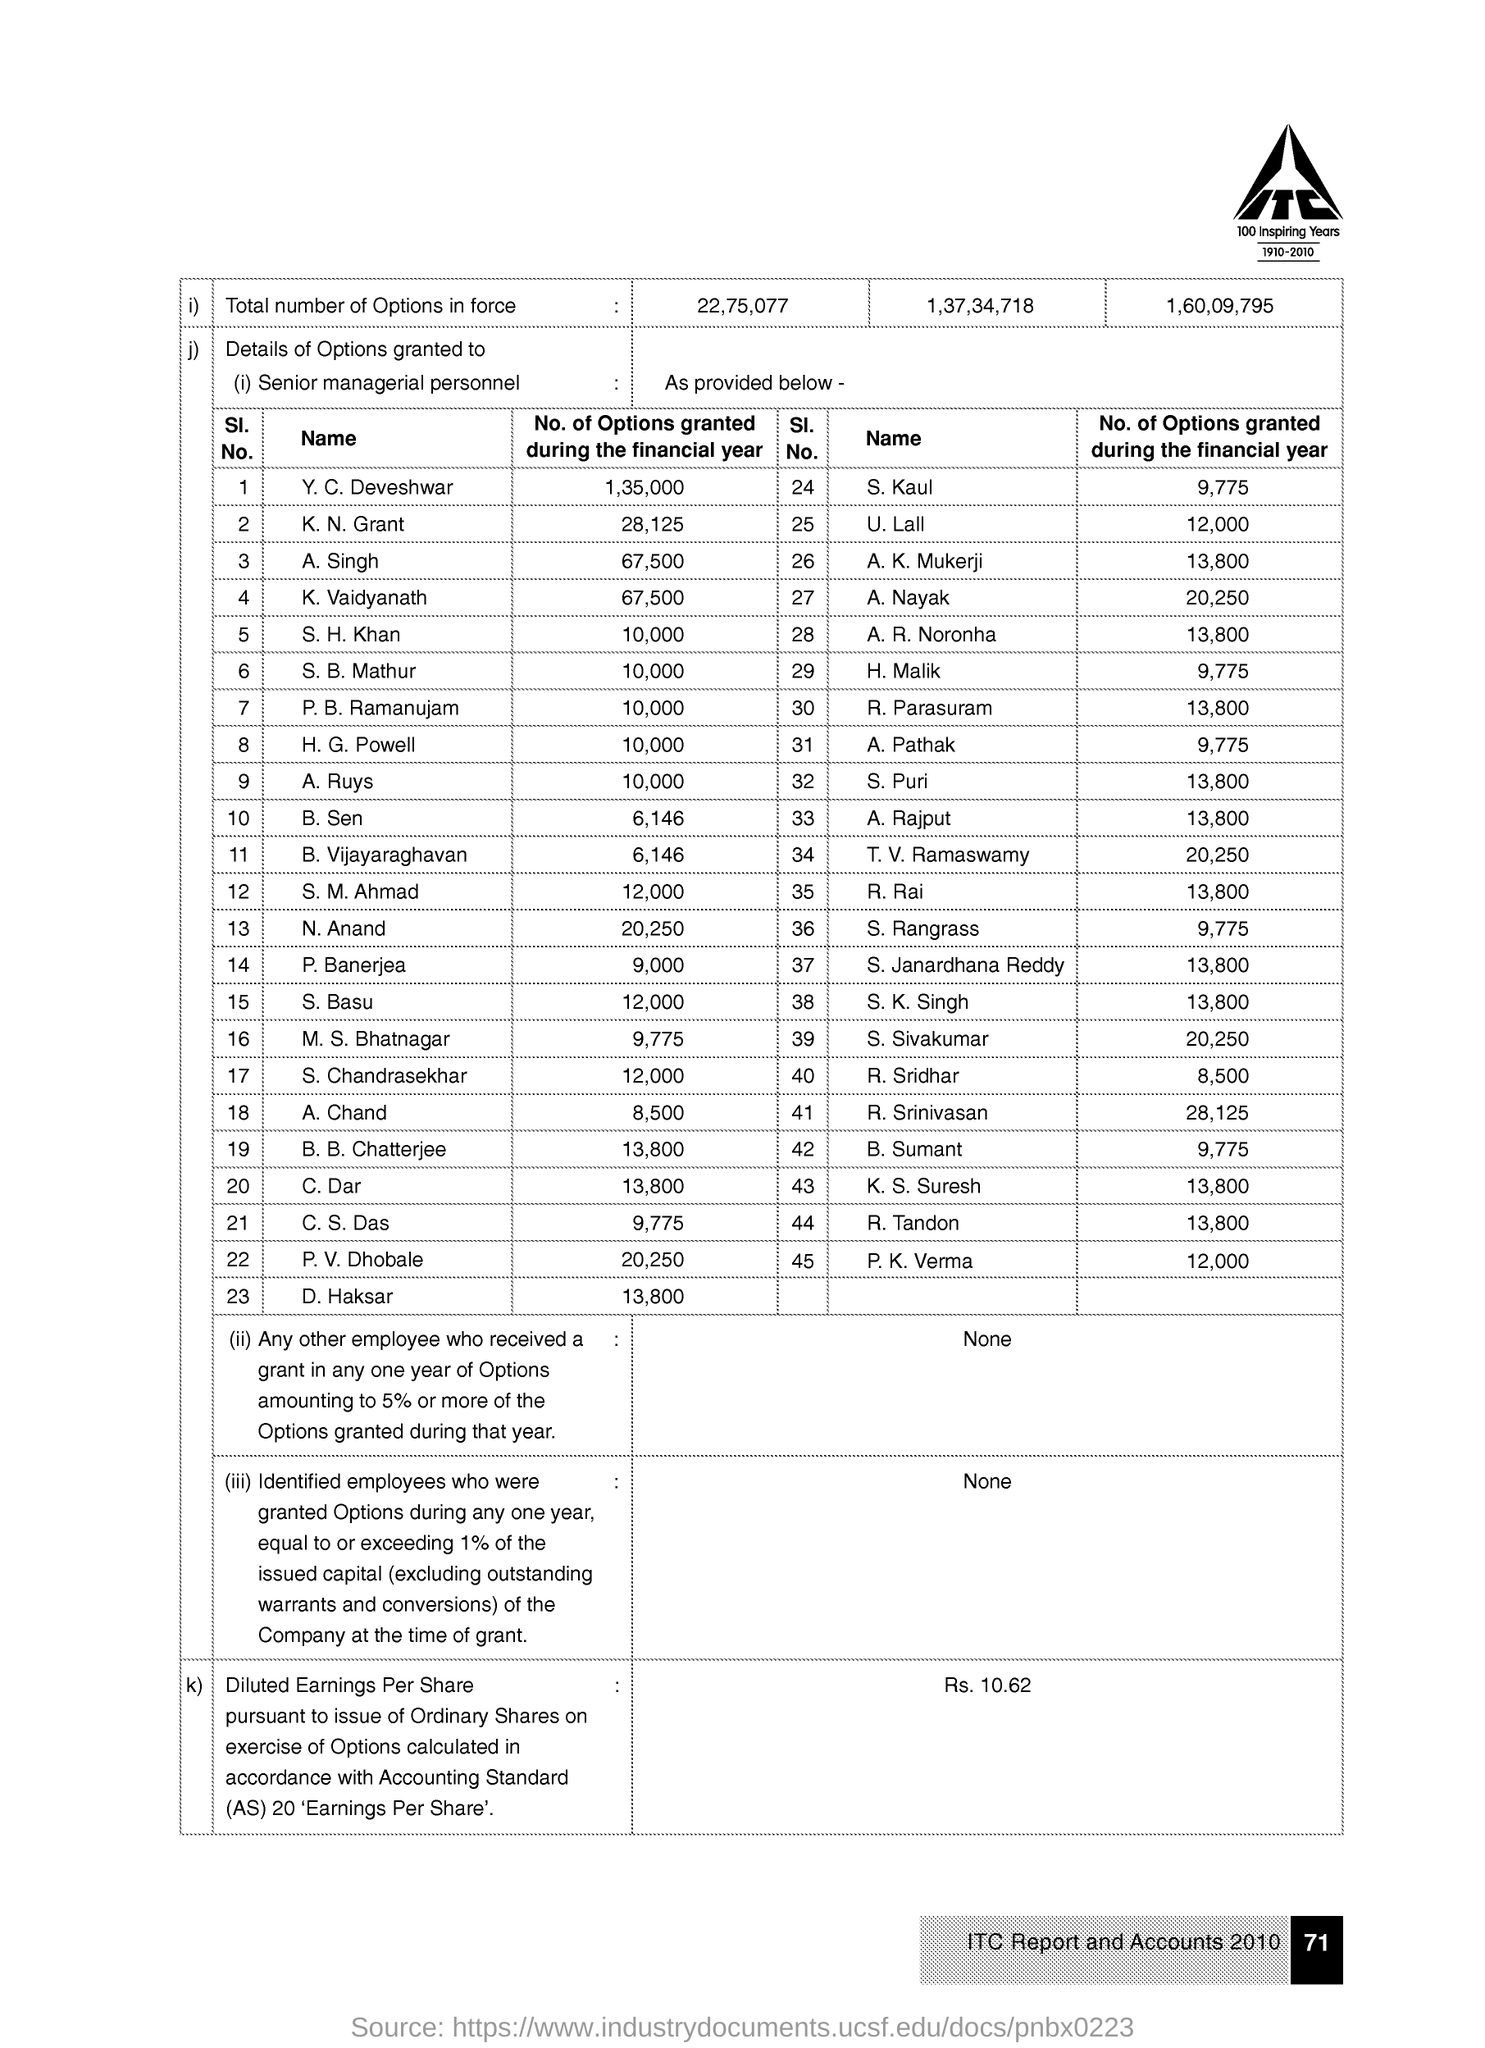Indicate a few pertinent items in this graphic. The page number given at the right bottom corner of the page is 71. The company logo features the bold text 'ITC'. P.K. Verma's serial number is 45. Y.C. Deveshwar was granted 1,35,000 stock options during the financial year. Mr. M. S. Bhatnagar was granted a total of 9,775 options during the financial year. 